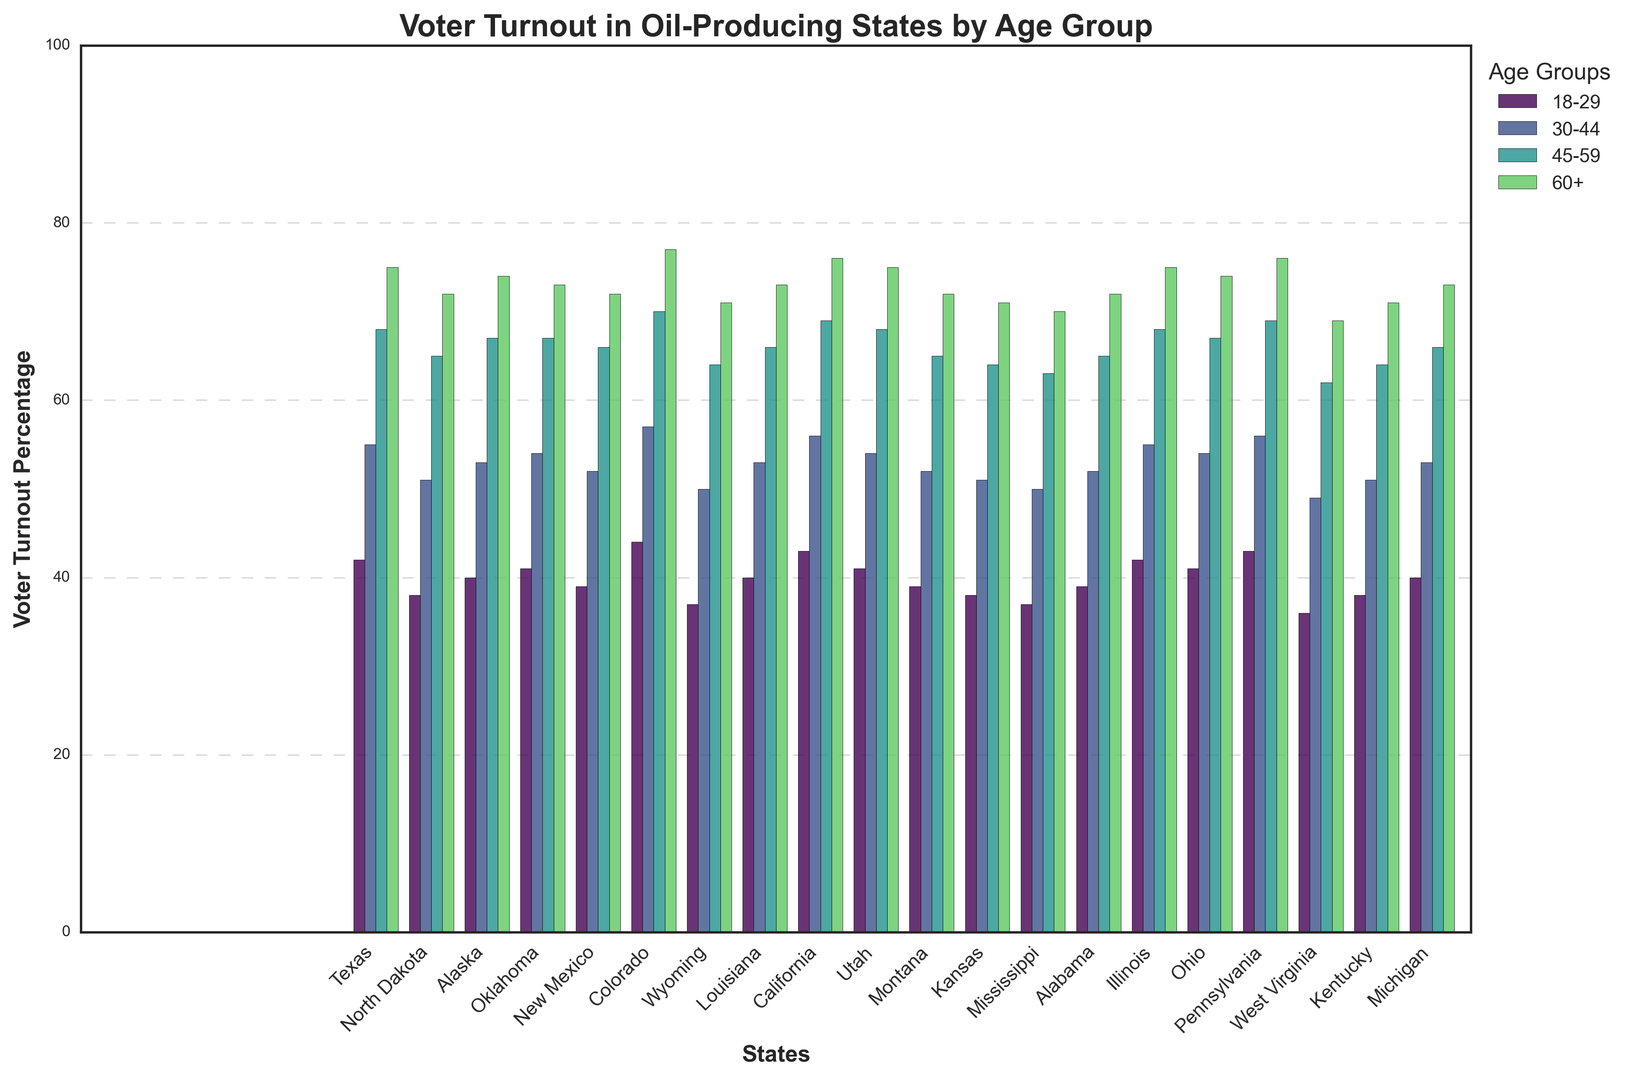Which state has the highest voter turnout for the 18-29 age group? Looking at the bars labeled for the 18-29 age group, the tallest bar corresponds to Colorado, indicating the highest turnout.
Answer: Colorado What is the difference in voter turnout between the 60+ and 18-29 age groups in Texas? The 60+ age group in Texas has a turnout of 75%, and the 18-29 age group has a turnout of 42%. The difference is 75% - 42% = 33%.
Answer: 33% Which age group shows the most consistent voter turnout across all states? By observing the spread and height consistency of bars across the states, it appears that the 60+ age group has the least variation in bar heights.
Answer: 60+ Is the voter turnout of the 45-59 age group higher in California or Ohio? The bar for the 45-59 age group is higher in California (69%) compared to Ohio (67%).
Answer: California How does the voter turnout in the 30-44 age group in Pennsylvania compare to the 60+ age group in Wyoming? Pennsylvania has a 30-44 age group turnout of 56%, while Wyoming has a 60+ age group turnout of 71%. Therefore, Pennsylvania's turnout is lower.
Answer: Lower Which state has the lowest voter turnout for the 60+ age group, and what is the percentage? By identifying the shortest bar for the 60+ age group, it is clear that West Virginia has the lowest percentage at 69%.
Answer: West Virginia, 69% In which state does the 30-44 age group show more than a 20% increase in voter turnout compared to the 18-29 age group? Colorado shows a 30-44 age group turnout of 57% compared to 44% for 18-29, which is an increase of 13%. No states show more than a 20% increase.
Answer: None What is the average voter turnout for the 30-44 age group across all states? Sum all the percentages of the 30-44 age group across states and divide by the number of states: 
(55 + 51 + 53 + 54 + 52 + 57 + 50 + 53 + 56 + 54 + 52 + 51 + 50 + 52 + 55 + 54 + 56 + 49 + 51 + 53) / 20 = 52.8%.
Answer: 52.8% How does voter turnout in the 18-29 age group in Colorado compare to the 18-29 turnout in Montana? Colorado has an 18-29 turnout of 44%, while Montana has a turnout of 39%. Colorado has a higher turnout.
Answer: Colorado Is there any state where the voter turnout decreases as age increases? By inspecting the data, no states show a consistent decrease in voter turnout as age increases.
Answer: No 